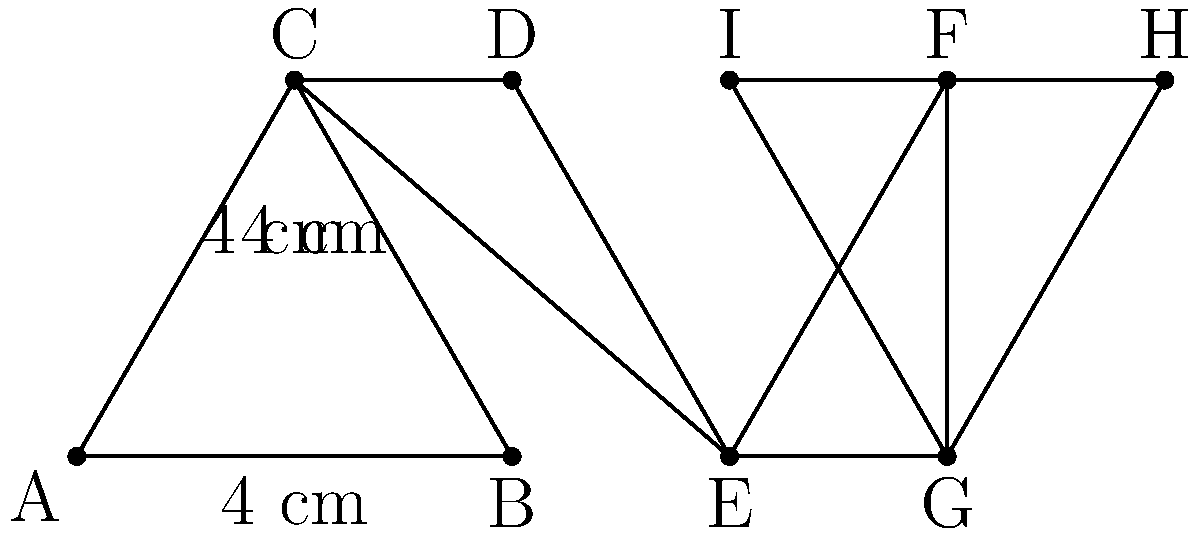For your latest avant-garde dress design, you're creating a star-shaped embellishment using triangular leather pieces. The embellishment consists of four equilateral triangles arranged as shown in the diagram, with each side measuring 4 cm. Calculate the total perimeter of this leather star embellishment. To find the total perimeter of the star-shaped embellishment, we need to follow these steps:

1. Identify the number of outer edges:
   The star shape has 8 outer edges (AB, BC, CD, DE, EF, FG, GH, HI).

2. Calculate the length of each edge:
   Each triangle is equilateral with side length 4 cm, so each outer edge is 4 cm long.

3. Calculate the total perimeter:
   Total perimeter = Number of outer edges × Length of each edge
   $$ \text{Total perimeter} = 8 \times 4\text{ cm} = 32\text{ cm} $$

Therefore, the total perimeter of the leather star embellishment is 32 cm.
Answer: 32 cm 